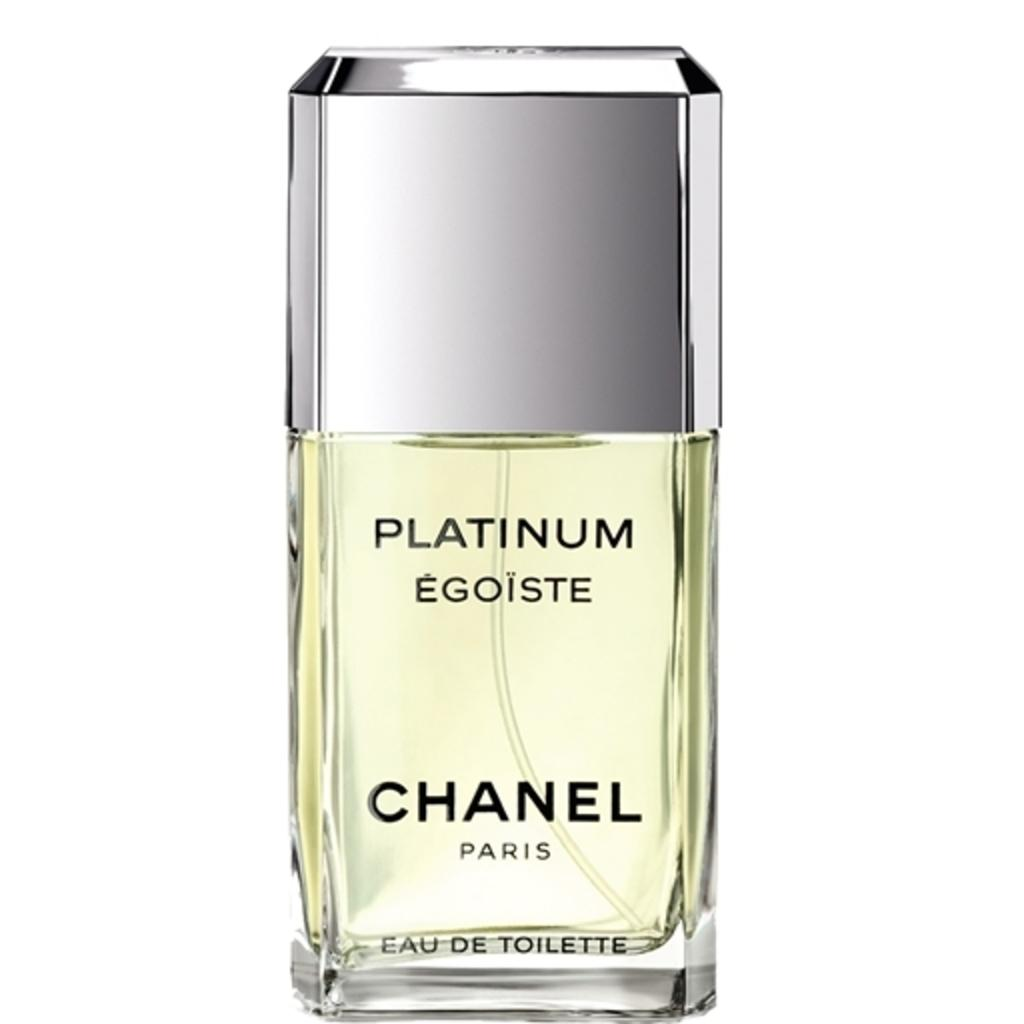<image>
Write a terse but informative summary of the picture. A bottle of Chanel Paris Eau de toilette. 